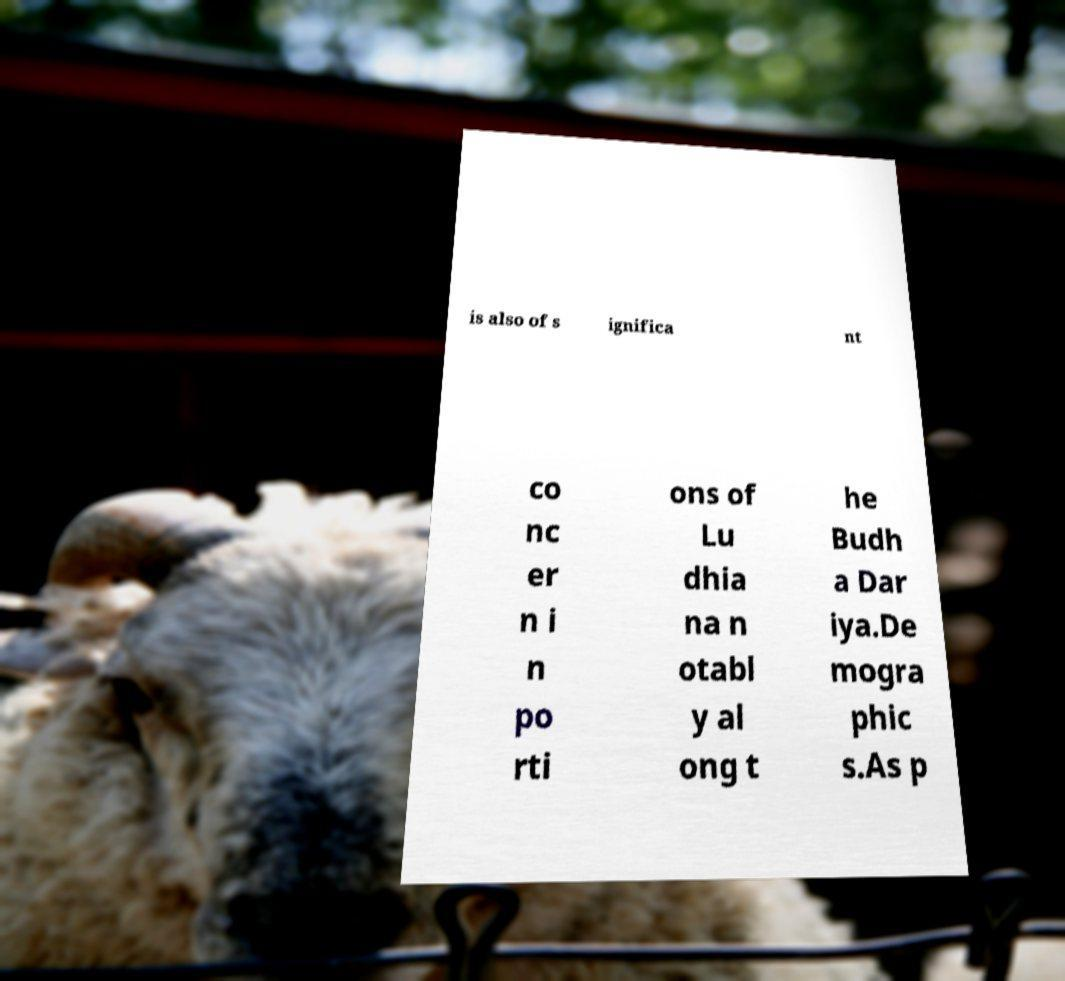Can you accurately transcribe the text from the provided image for me? is also of s ignifica nt co nc er n i n po rti ons of Lu dhia na n otabl y al ong t he Budh a Dar iya.De mogra phic s.As p 